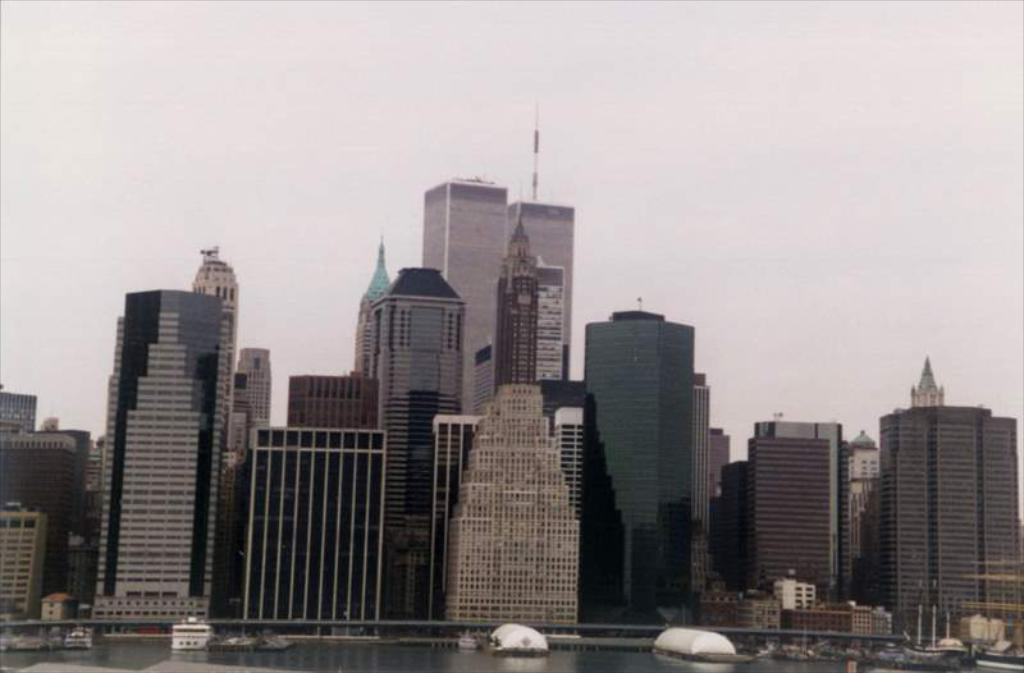What type of structures can be seen in the image? There are many buildings in the image. What is located near the buildings? There is water near the buildings. What is on the water in the image? There are boats on the water. What can be seen in the background of the image? The sky is visible in the background of the image. Can you see anyone's toes on the roof of the buildings in the image? There are no people visible in the image, and therefore no toes can be seen on the roof of the buildings. 